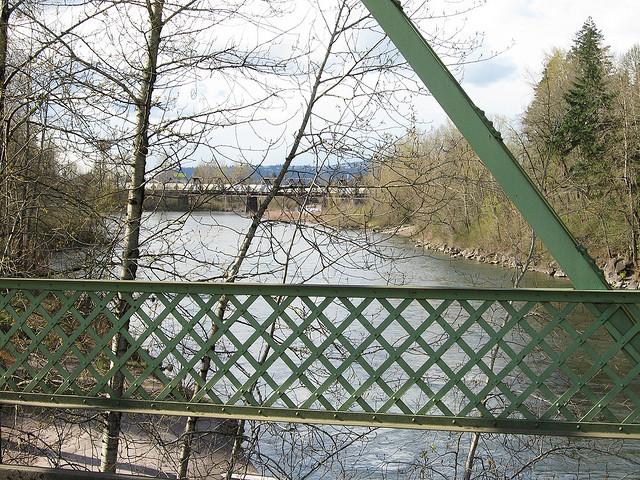What color is the railing?
Write a very short answer. Green. Is the sky a vivid color?
Write a very short answer. No. Is that a bridge?
Keep it brief. Yes. 